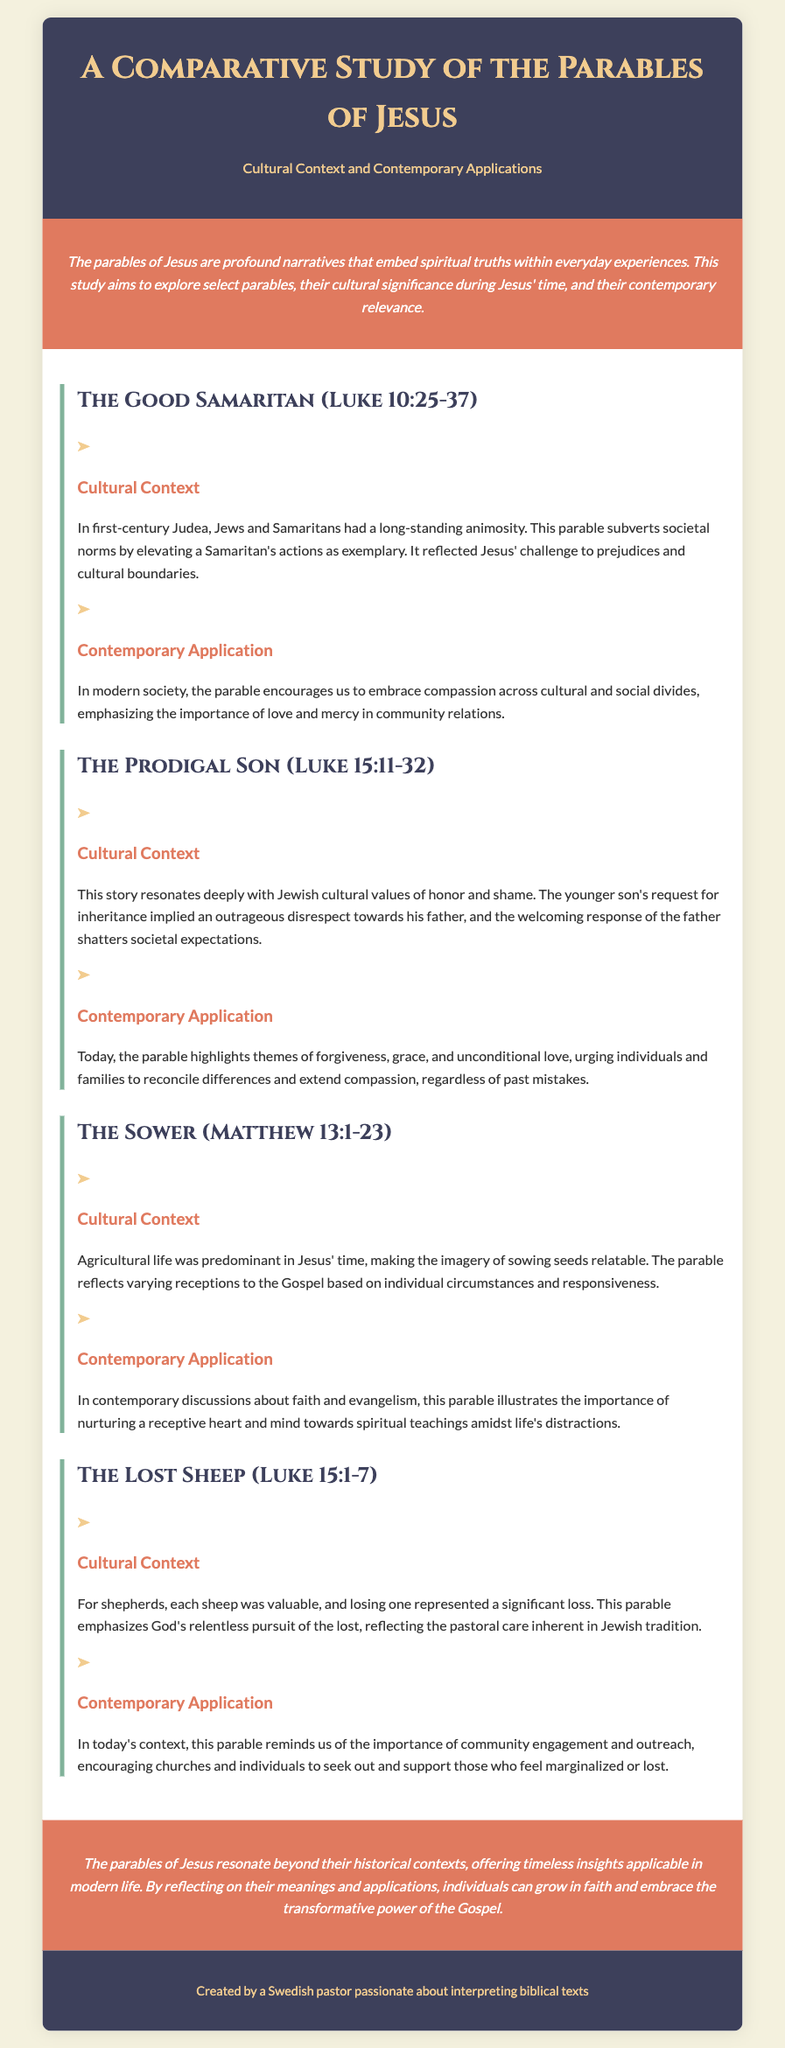What is the title of the document? The title appears in the header section of the document, which is "A Comparative Study of the Parables of Jesus."
Answer: A Comparative Study of the Parables of Jesus How many parables are discussed in the document? The document includes a section for each parable, specifically mentioning four parables in the text.
Answer: Four What is the cultural context of "The Good Samaritan"? The cultural context provides insight into the relationships between Jews and Samaritans during Jesus' time, highlighting long-standing animosity.
Answer: Long-standing animosity What is the contemporary application of "The Prodigal Son"? The contemporary application emphasizes forgiveness, grace, and unconditional love, urging reconciliation.
Answer: Forgiveness, grace, and unconditional love What significant theme does "The Sower" illustrate? The parable relates to the individual circumstances affecting the reception of the Gospel, illustrating the varying responses.
Answer: Varying receptions to the Gospel What metaphor is used in "The Lost Sheep"? The metaphor reflects the significance of each individual and the value attributed to those who are lost.
Answer: Each sheep was valuable What do the parables suggest about the relationships across cultural divides? The parables call for compassion and support for those from different backgrounds, emphasizing love and mercy.
Answer: Compassion across cultural divides What is highlighted about God's nature in "The Lost Sheep"? This parable emphasizes God's relentless pursuit of the lost, showcasing His care for individuals.
Answer: Relentless pursuit of the lost What are the last words of the conclusion section? The last words summarize the timeless insights of the parables and their relevance in modern life.
Answer: Transformative power of the Gospel 